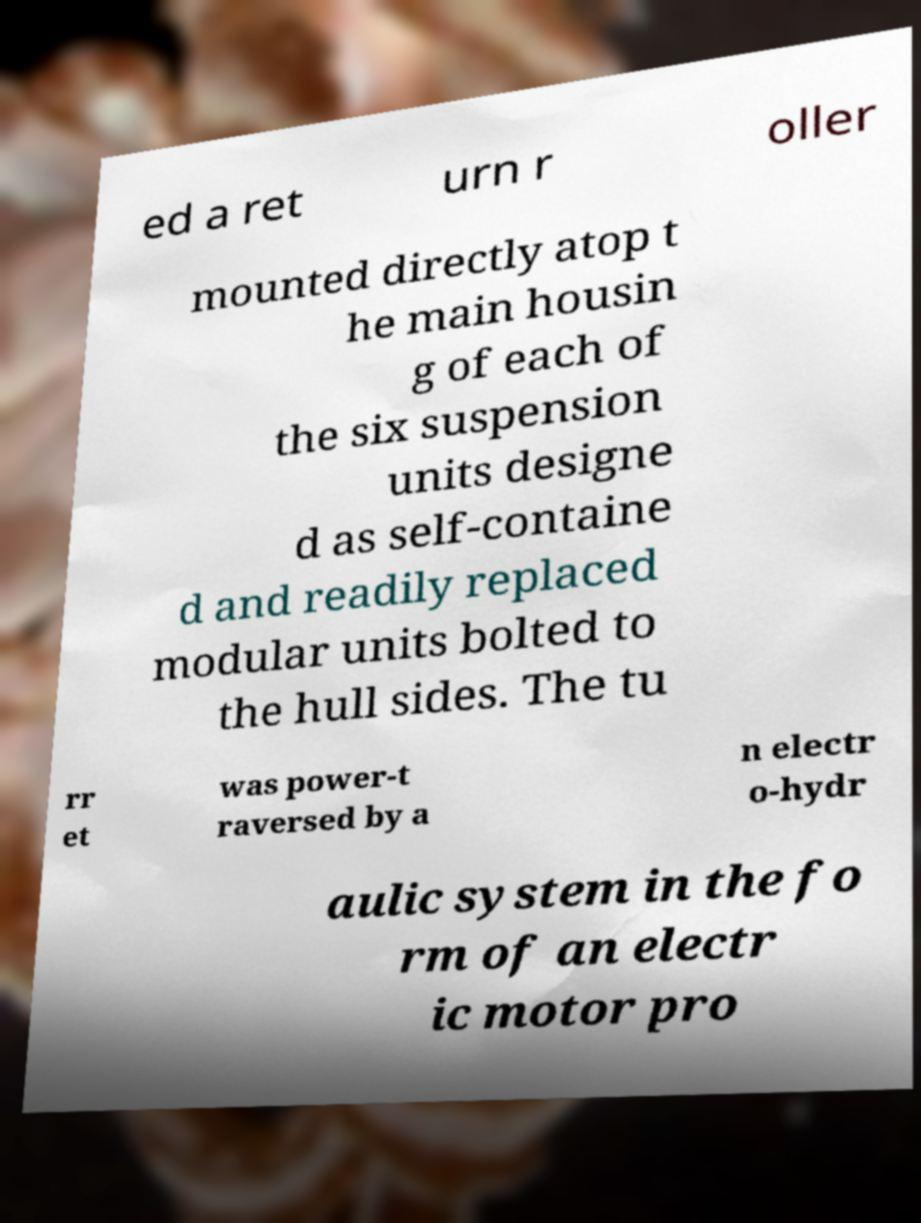Please identify and transcribe the text found in this image. ed a ret urn r oller mounted directly atop t he main housin g of each of the six suspension units designe d as self-containe d and readily replaced modular units bolted to the hull sides. The tu rr et was power-t raversed by a n electr o-hydr aulic system in the fo rm of an electr ic motor pro 